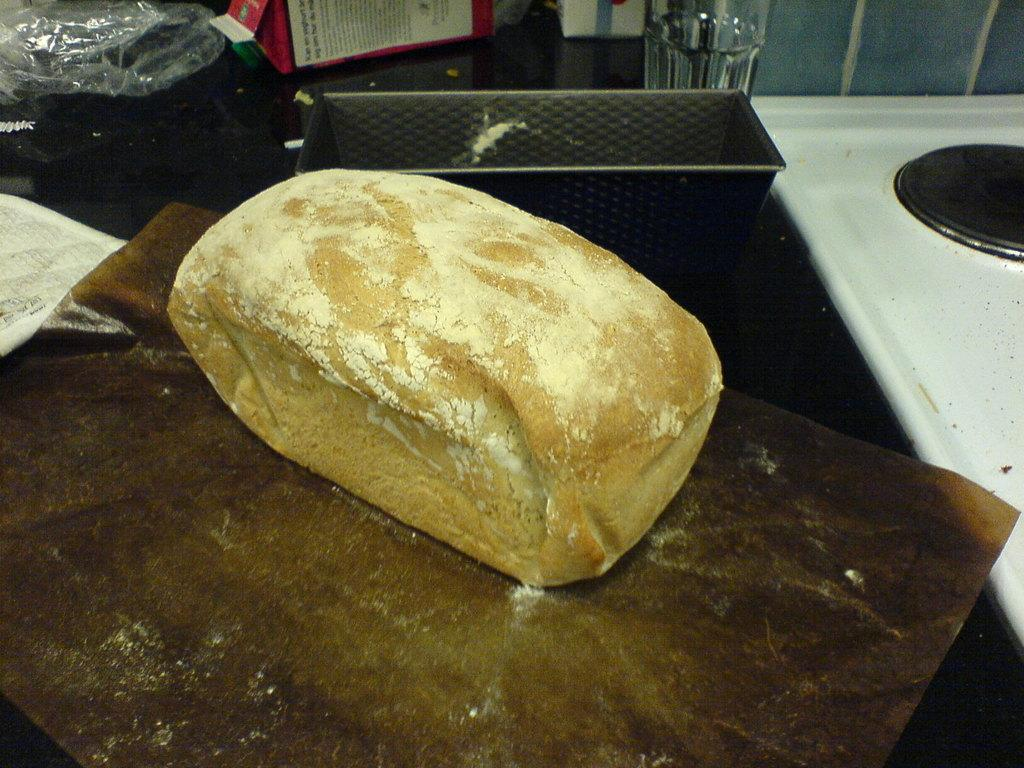What is the main object in the image? There is a bread brick with powder in the image. How is the bread brick positioned in the image? The bread brick is placed on brown paper. What other objects can be seen in the image? There is a glass object, a white stove, a container, and a cover in the image. What type of quartz is used to decorate the bread brick in the image? There is no quartz present in the image; it features a bread brick with powder on brown paper. What color is the underwear worn by the person in the image? There is no person or underwear present in the image. 